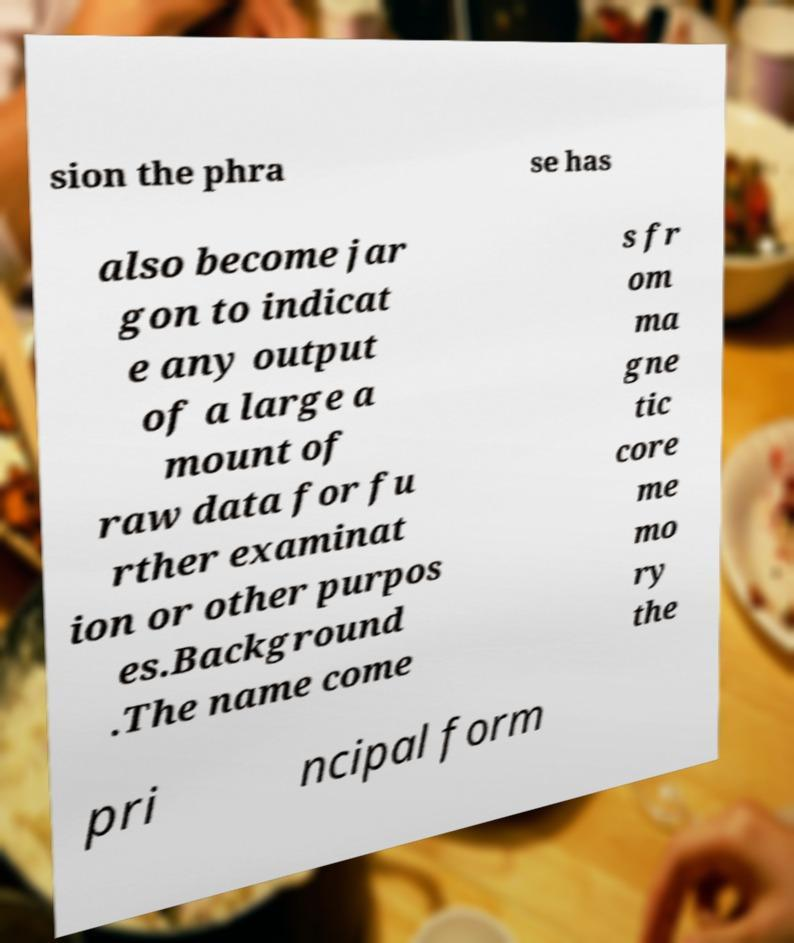Please read and relay the text visible in this image. What does it say? sion the phra se has also become jar gon to indicat e any output of a large a mount of raw data for fu rther examinat ion or other purpos es.Background .The name come s fr om ma gne tic core me mo ry the pri ncipal form 